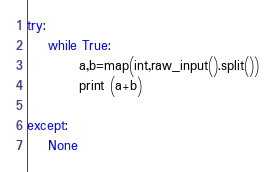Convert code to text. <code><loc_0><loc_0><loc_500><loc_500><_Python_>try:
    while True:
          a,b=map(int,raw_input().split())
          print (a+b)

except:
    None</code> 